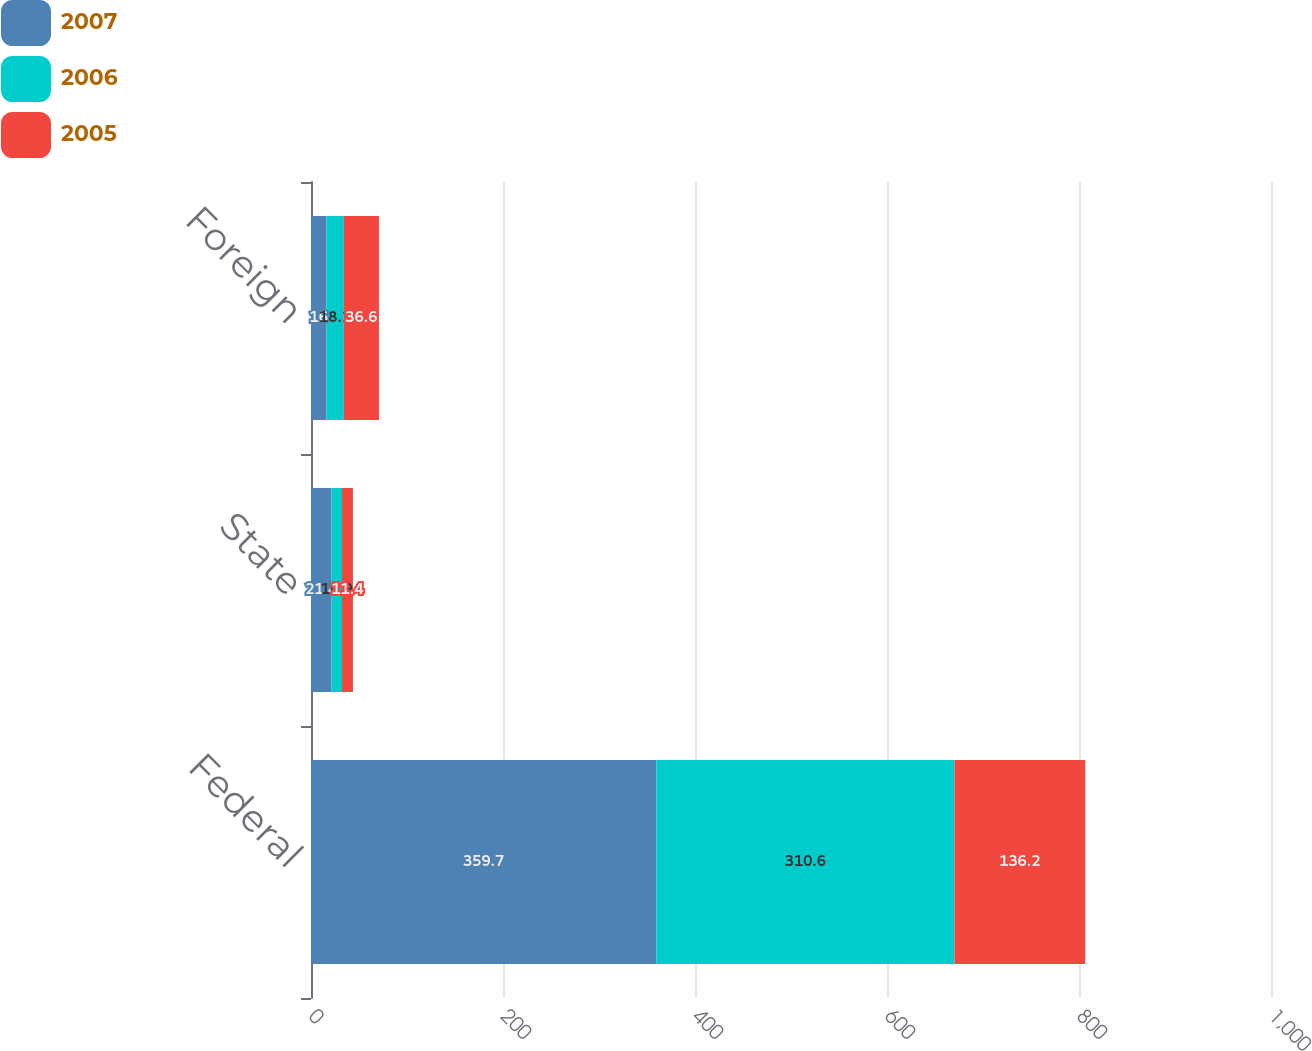<chart> <loc_0><loc_0><loc_500><loc_500><stacked_bar_chart><ecel><fcel>Federal<fcel>State<fcel>Foreign<nl><fcel>2007<fcel>359.7<fcel>21.4<fcel>16<nl><fcel>2006<fcel>310.6<fcel>10.9<fcel>18.2<nl><fcel>2005<fcel>136.2<fcel>11.4<fcel>36.6<nl></chart> 